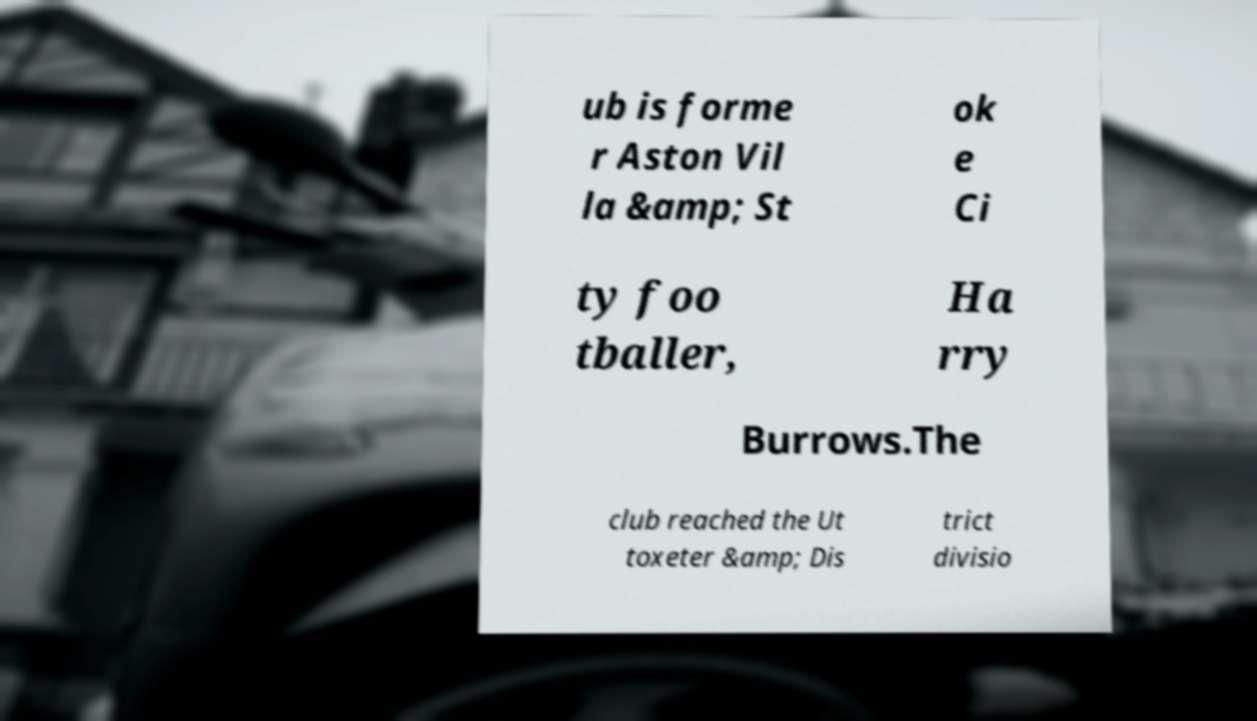There's text embedded in this image that I need extracted. Can you transcribe it verbatim? ub is forme r Aston Vil la &amp; St ok e Ci ty foo tballer, Ha rry Burrows.The club reached the Ut toxeter &amp; Dis trict divisio 